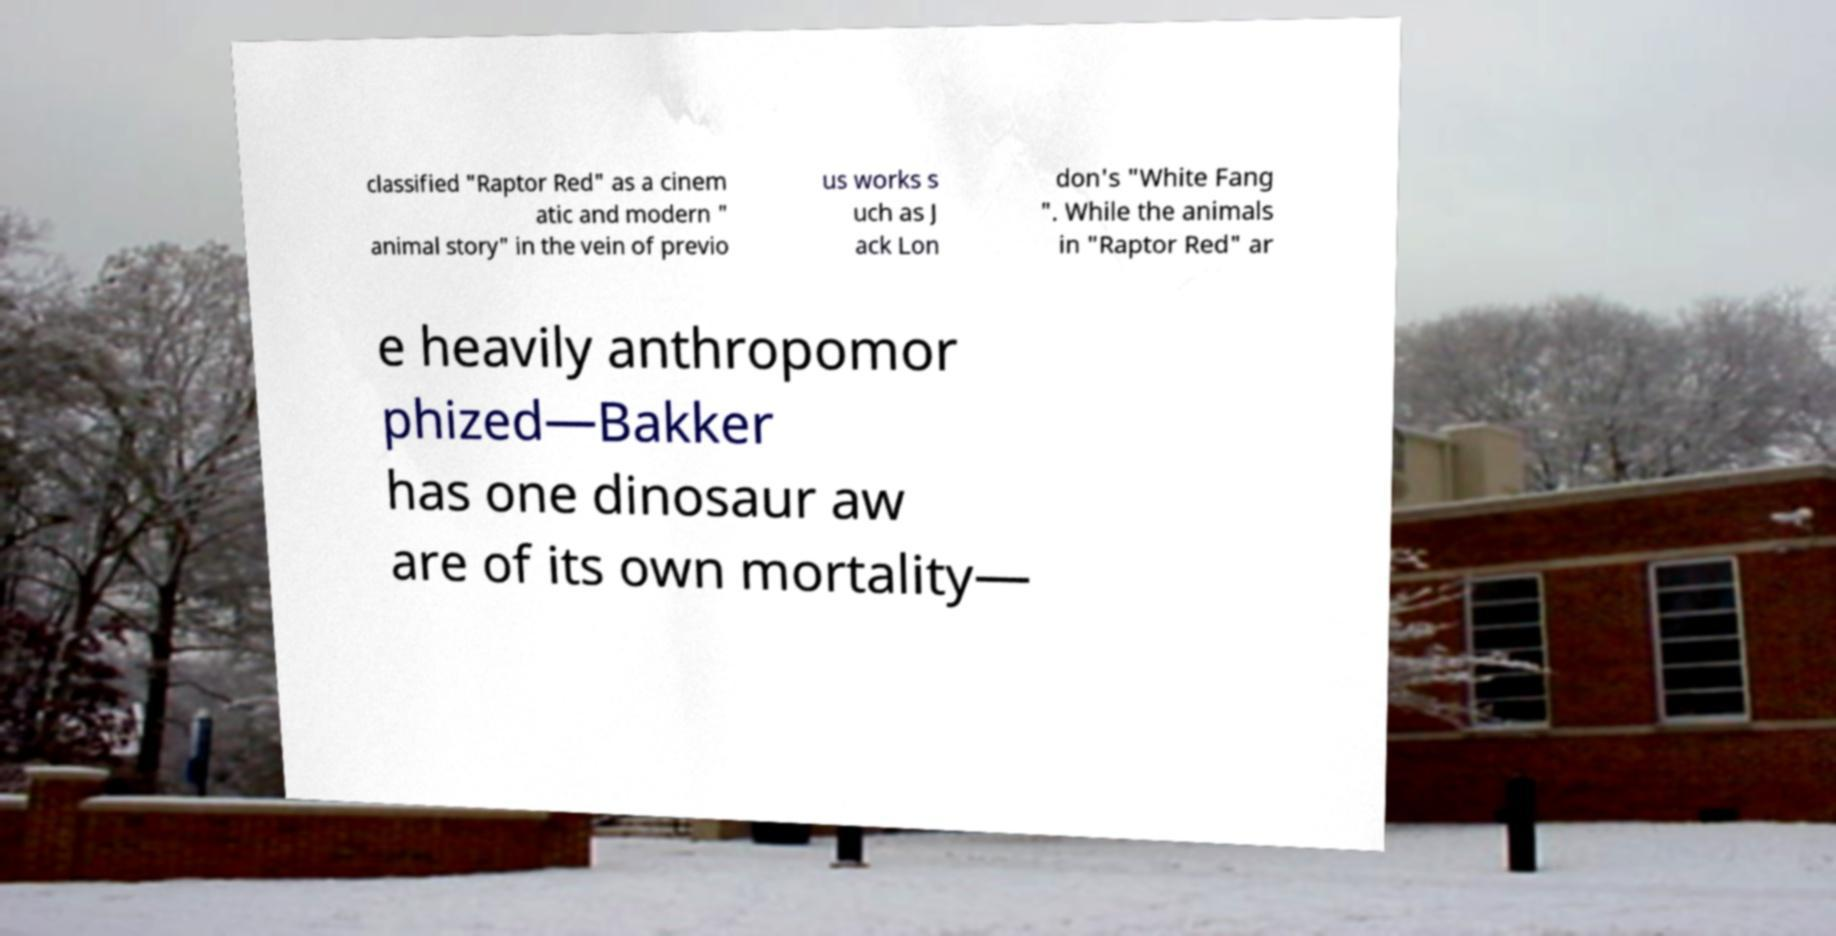Can you accurately transcribe the text from the provided image for me? classified "Raptor Red" as a cinem atic and modern " animal story" in the vein of previo us works s uch as J ack Lon don's "White Fang ". While the animals in "Raptor Red" ar e heavily anthropomor phized—Bakker has one dinosaur aw are of its own mortality— 